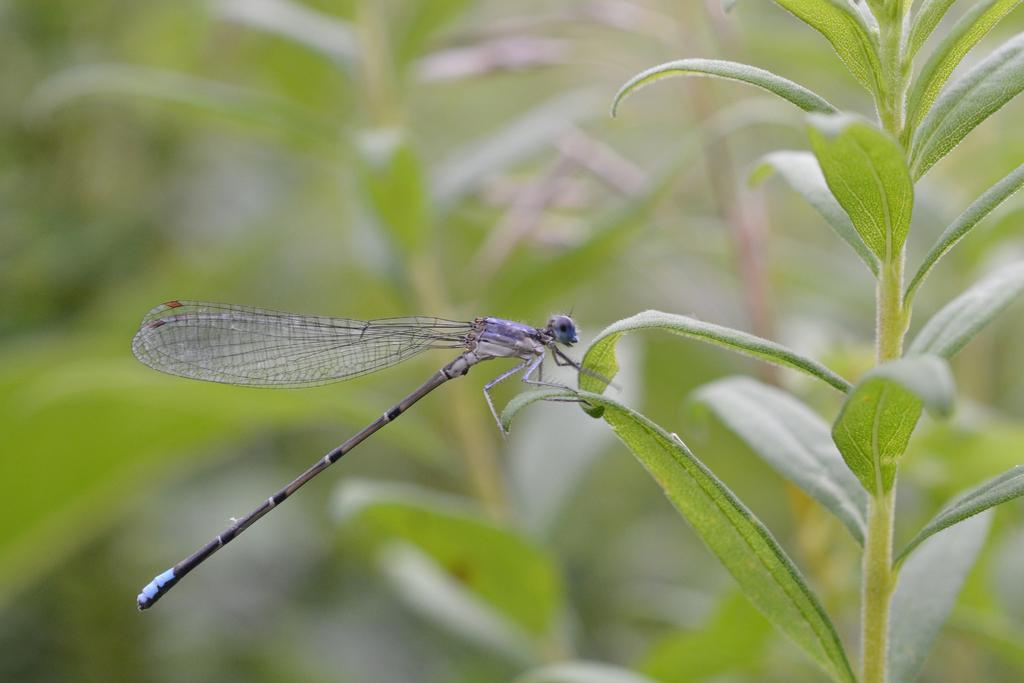What is present in the image? There is an insect in the image. Can you describe the insect? The insect is purple in color. Where is the insect located? The insect is on a leaf. What is the leaf part of? The leaf is part of a plant. What is the color of the plant? The plant is green in color. How would you describe the background of the image? The background of the image is blurry. What else can be seen in the background? There are plants visible in the background. How does the insect's father feel about the insect's choice of color? There is no information about the insect's father or feelings in the image, as it only shows an insect on a leaf. 